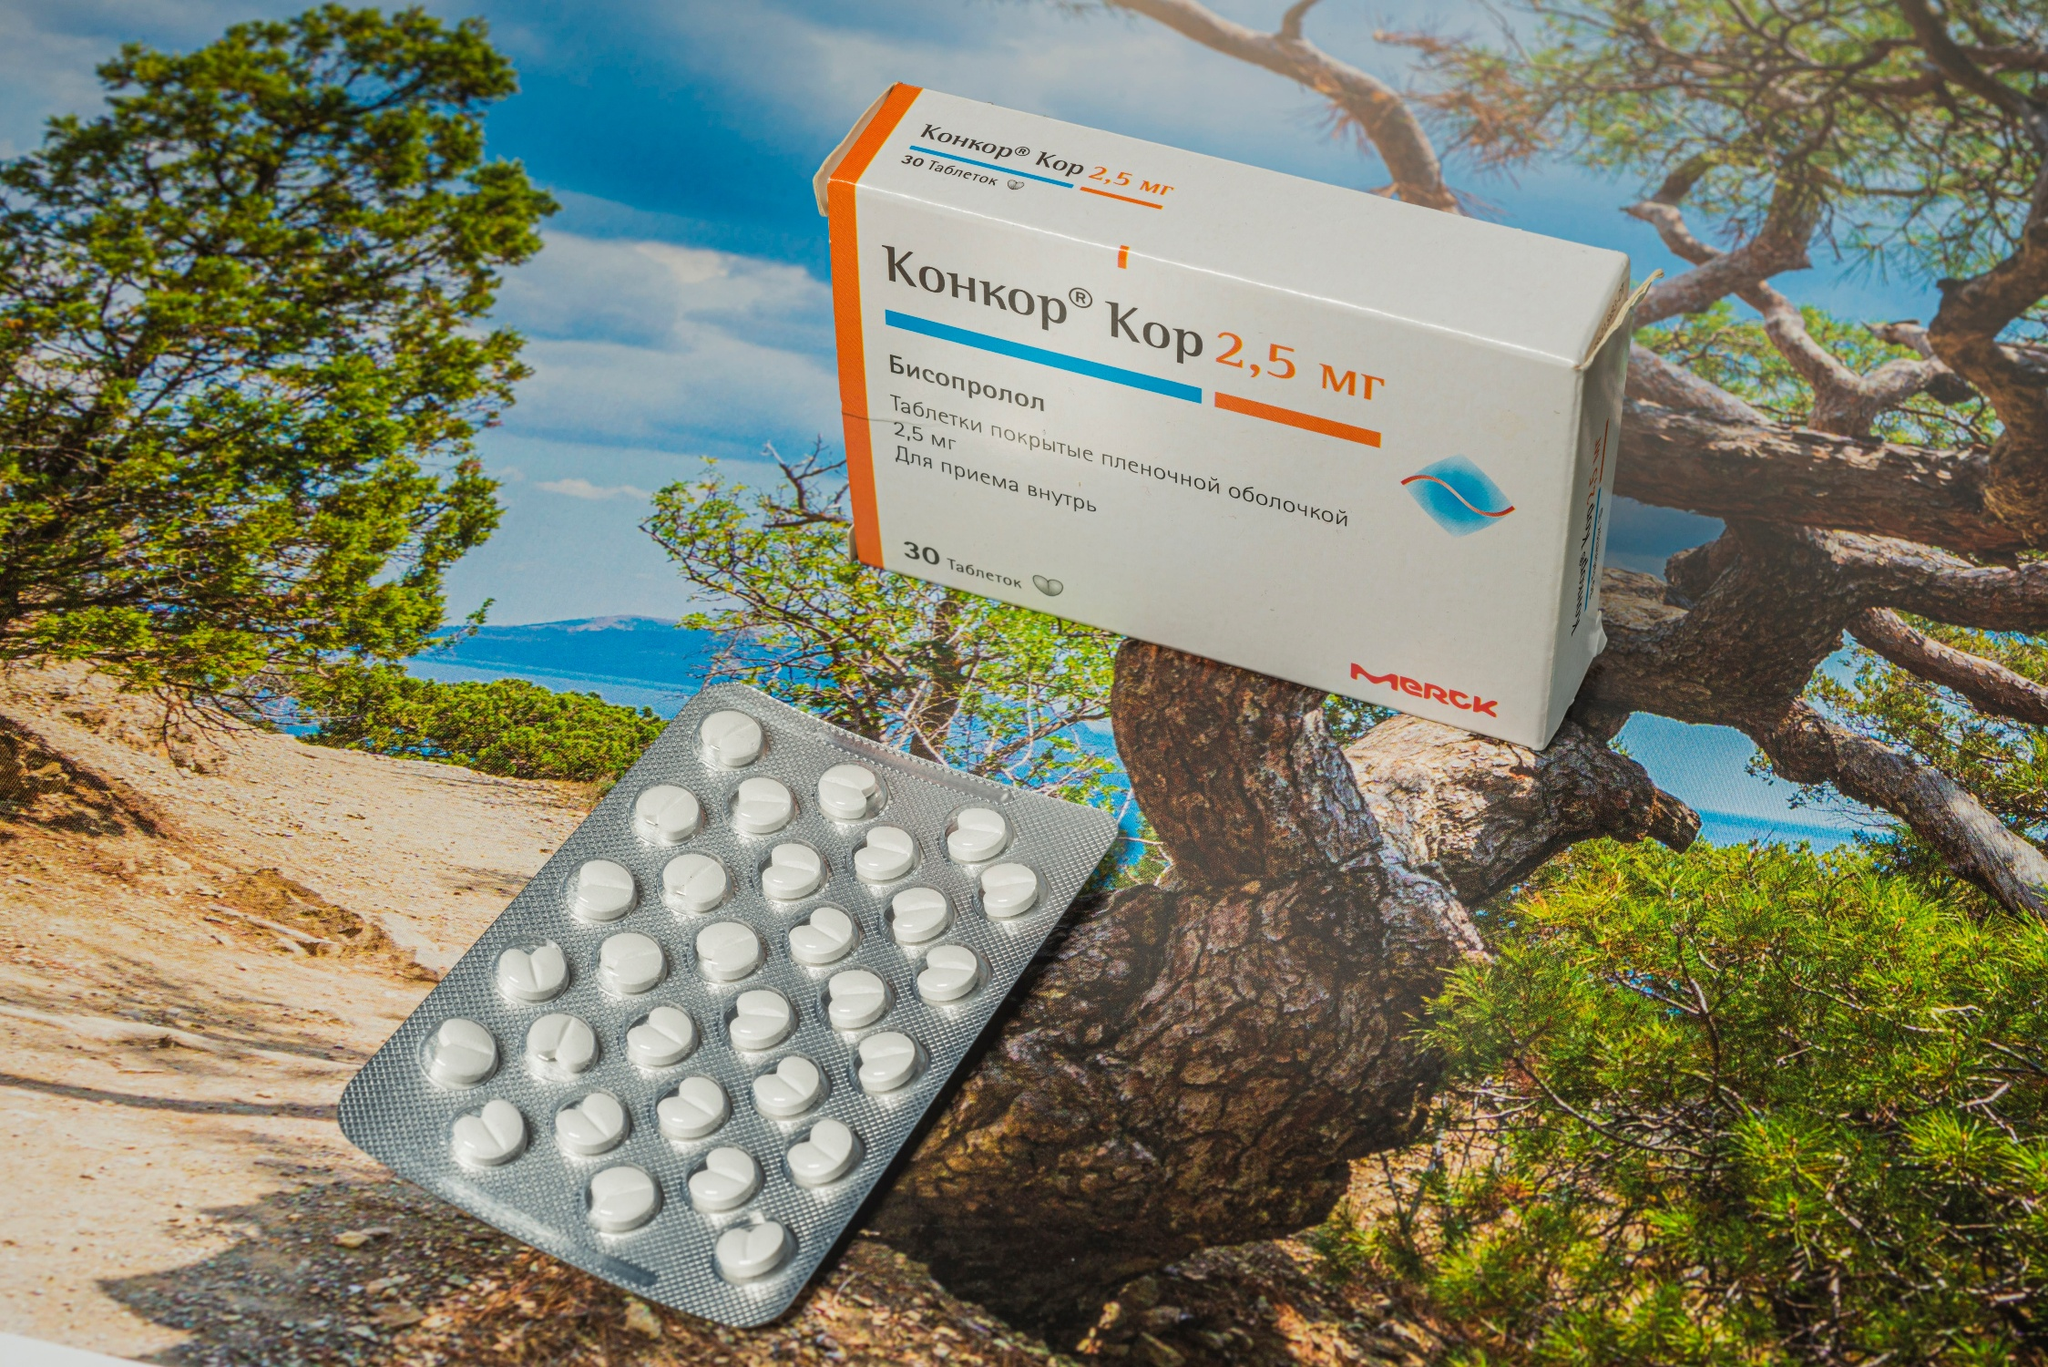What does the specific location shown in the image suggest about the marketing or intended message of these medications? The strategic choice of location, such as a tranquil and picturesque cliff overlooking the ocean, may suggest a marketing narrative that associates the medication with peace, wellness, and natural beauty. This environment could be implying that the medication helps one to achieve a state of equilibrium and health, as serene as the oceanic backdrop, possibly intending to evoke a feeling of reassurance and trust in the product. 